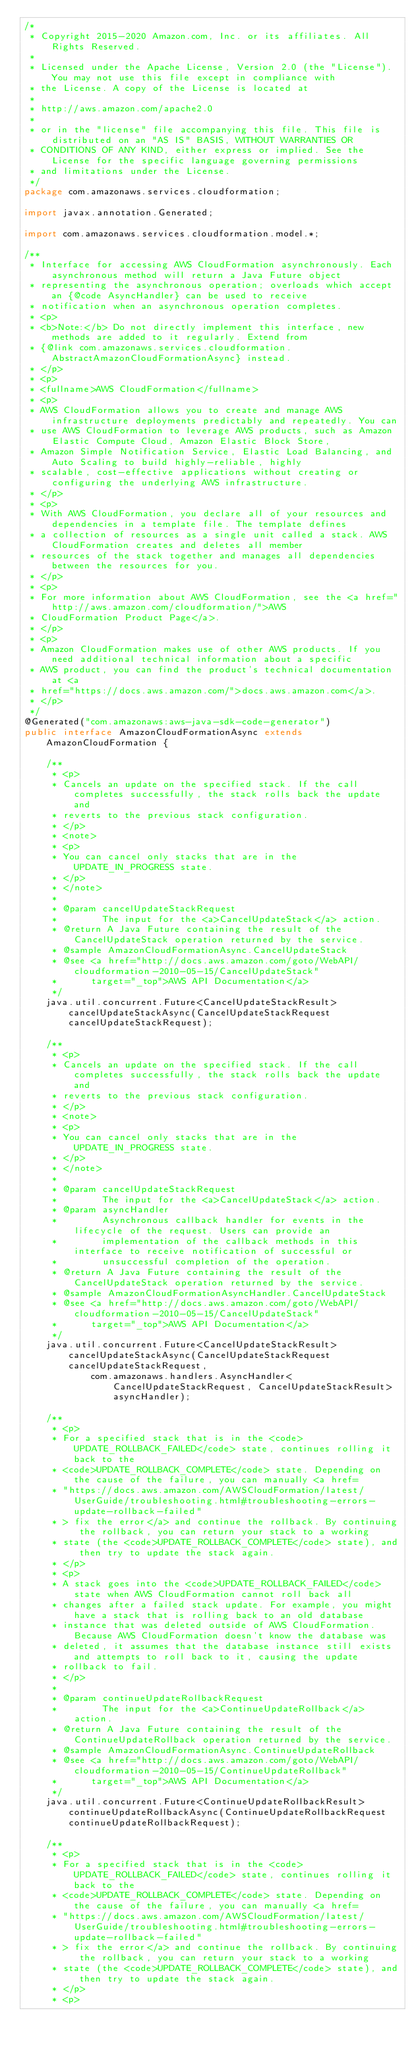Convert code to text. <code><loc_0><loc_0><loc_500><loc_500><_Java_>/*
 * Copyright 2015-2020 Amazon.com, Inc. or its affiliates. All Rights Reserved.
 * 
 * Licensed under the Apache License, Version 2.0 (the "License"). You may not use this file except in compliance with
 * the License. A copy of the License is located at
 * 
 * http://aws.amazon.com/apache2.0
 * 
 * or in the "license" file accompanying this file. This file is distributed on an "AS IS" BASIS, WITHOUT WARRANTIES OR
 * CONDITIONS OF ANY KIND, either express or implied. See the License for the specific language governing permissions
 * and limitations under the License.
 */
package com.amazonaws.services.cloudformation;

import javax.annotation.Generated;

import com.amazonaws.services.cloudformation.model.*;

/**
 * Interface for accessing AWS CloudFormation asynchronously. Each asynchronous method will return a Java Future object
 * representing the asynchronous operation; overloads which accept an {@code AsyncHandler} can be used to receive
 * notification when an asynchronous operation completes.
 * <p>
 * <b>Note:</b> Do not directly implement this interface, new methods are added to it regularly. Extend from
 * {@link com.amazonaws.services.cloudformation.AbstractAmazonCloudFormationAsync} instead.
 * </p>
 * <p>
 * <fullname>AWS CloudFormation</fullname>
 * <p>
 * AWS CloudFormation allows you to create and manage AWS infrastructure deployments predictably and repeatedly. You can
 * use AWS CloudFormation to leverage AWS products, such as Amazon Elastic Compute Cloud, Amazon Elastic Block Store,
 * Amazon Simple Notification Service, Elastic Load Balancing, and Auto Scaling to build highly-reliable, highly
 * scalable, cost-effective applications without creating or configuring the underlying AWS infrastructure.
 * </p>
 * <p>
 * With AWS CloudFormation, you declare all of your resources and dependencies in a template file. The template defines
 * a collection of resources as a single unit called a stack. AWS CloudFormation creates and deletes all member
 * resources of the stack together and manages all dependencies between the resources for you.
 * </p>
 * <p>
 * For more information about AWS CloudFormation, see the <a href="http://aws.amazon.com/cloudformation/">AWS
 * CloudFormation Product Page</a>.
 * </p>
 * <p>
 * Amazon CloudFormation makes use of other AWS products. If you need additional technical information about a specific
 * AWS product, you can find the product's technical documentation at <a
 * href="https://docs.aws.amazon.com/">docs.aws.amazon.com</a>.
 * </p>
 */
@Generated("com.amazonaws:aws-java-sdk-code-generator")
public interface AmazonCloudFormationAsync extends AmazonCloudFormation {

    /**
     * <p>
     * Cancels an update on the specified stack. If the call completes successfully, the stack rolls back the update and
     * reverts to the previous stack configuration.
     * </p>
     * <note>
     * <p>
     * You can cancel only stacks that are in the UPDATE_IN_PROGRESS state.
     * </p>
     * </note>
     * 
     * @param cancelUpdateStackRequest
     *        The input for the <a>CancelUpdateStack</a> action.
     * @return A Java Future containing the result of the CancelUpdateStack operation returned by the service.
     * @sample AmazonCloudFormationAsync.CancelUpdateStack
     * @see <a href="http://docs.aws.amazon.com/goto/WebAPI/cloudformation-2010-05-15/CancelUpdateStack"
     *      target="_top">AWS API Documentation</a>
     */
    java.util.concurrent.Future<CancelUpdateStackResult> cancelUpdateStackAsync(CancelUpdateStackRequest cancelUpdateStackRequest);

    /**
     * <p>
     * Cancels an update on the specified stack. If the call completes successfully, the stack rolls back the update and
     * reverts to the previous stack configuration.
     * </p>
     * <note>
     * <p>
     * You can cancel only stacks that are in the UPDATE_IN_PROGRESS state.
     * </p>
     * </note>
     * 
     * @param cancelUpdateStackRequest
     *        The input for the <a>CancelUpdateStack</a> action.
     * @param asyncHandler
     *        Asynchronous callback handler for events in the lifecycle of the request. Users can provide an
     *        implementation of the callback methods in this interface to receive notification of successful or
     *        unsuccessful completion of the operation.
     * @return A Java Future containing the result of the CancelUpdateStack operation returned by the service.
     * @sample AmazonCloudFormationAsyncHandler.CancelUpdateStack
     * @see <a href="http://docs.aws.amazon.com/goto/WebAPI/cloudformation-2010-05-15/CancelUpdateStack"
     *      target="_top">AWS API Documentation</a>
     */
    java.util.concurrent.Future<CancelUpdateStackResult> cancelUpdateStackAsync(CancelUpdateStackRequest cancelUpdateStackRequest,
            com.amazonaws.handlers.AsyncHandler<CancelUpdateStackRequest, CancelUpdateStackResult> asyncHandler);

    /**
     * <p>
     * For a specified stack that is in the <code>UPDATE_ROLLBACK_FAILED</code> state, continues rolling it back to the
     * <code>UPDATE_ROLLBACK_COMPLETE</code> state. Depending on the cause of the failure, you can manually <a href=
     * "https://docs.aws.amazon.com/AWSCloudFormation/latest/UserGuide/troubleshooting.html#troubleshooting-errors-update-rollback-failed"
     * > fix the error</a> and continue the rollback. By continuing the rollback, you can return your stack to a working
     * state (the <code>UPDATE_ROLLBACK_COMPLETE</code> state), and then try to update the stack again.
     * </p>
     * <p>
     * A stack goes into the <code>UPDATE_ROLLBACK_FAILED</code> state when AWS CloudFormation cannot roll back all
     * changes after a failed stack update. For example, you might have a stack that is rolling back to an old database
     * instance that was deleted outside of AWS CloudFormation. Because AWS CloudFormation doesn't know the database was
     * deleted, it assumes that the database instance still exists and attempts to roll back to it, causing the update
     * rollback to fail.
     * </p>
     * 
     * @param continueUpdateRollbackRequest
     *        The input for the <a>ContinueUpdateRollback</a> action.
     * @return A Java Future containing the result of the ContinueUpdateRollback operation returned by the service.
     * @sample AmazonCloudFormationAsync.ContinueUpdateRollback
     * @see <a href="http://docs.aws.amazon.com/goto/WebAPI/cloudformation-2010-05-15/ContinueUpdateRollback"
     *      target="_top">AWS API Documentation</a>
     */
    java.util.concurrent.Future<ContinueUpdateRollbackResult> continueUpdateRollbackAsync(ContinueUpdateRollbackRequest continueUpdateRollbackRequest);

    /**
     * <p>
     * For a specified stack that is in the <code>UPDATE_ROLLBACK_FAILED</code> state, continues rolling it back to the
     * <code>UPDATE_ROLLBACK_COMPLETE</code> state. Depending on the cause of the failure, you can manually <a href=
     * "https://docs.aws.amazon.com/AWSCloudFormation/latest/UserGuide/troubleshooting.html#troubleshooting-errors-update-rollback-failed"
     * > fix the error</a> and continue the rollback. By continuing the rollback, you can return your stack to a working
     * state (the <code>UPDATE_ROLLBACK_COMPLETE</code> state), and then try to update the stack again.
     * </p>
     * <p></code> 